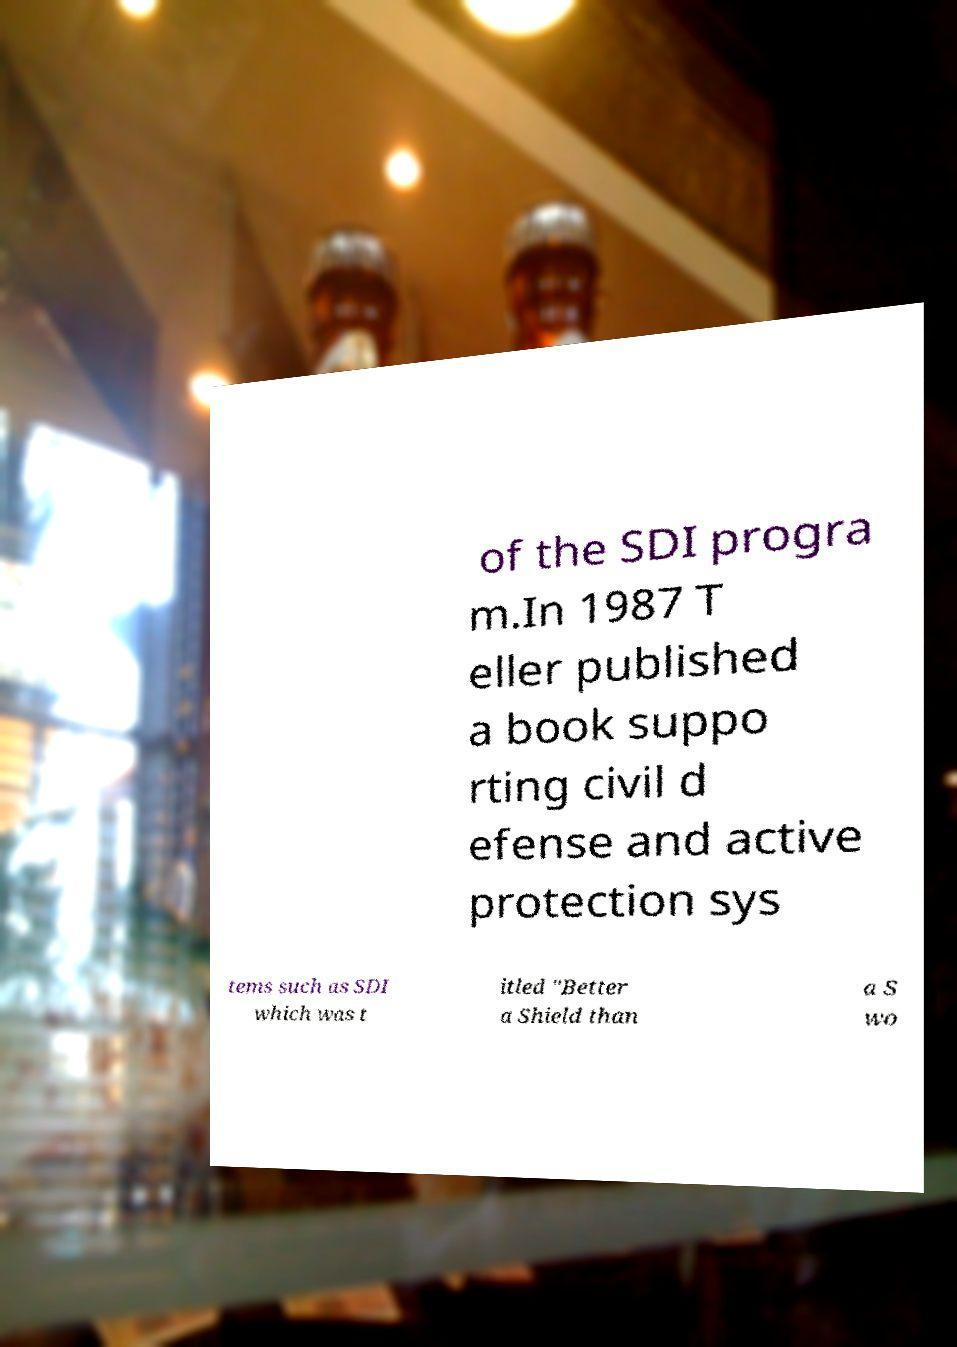What messages or text are displayed in this image? I need them in a readable, typed format. of the SDI progra m.In 1987 T eller published a book suppo rting civil d efense and active protection sys tems such as SDI which was t itled "Better a Shield than a S wo 